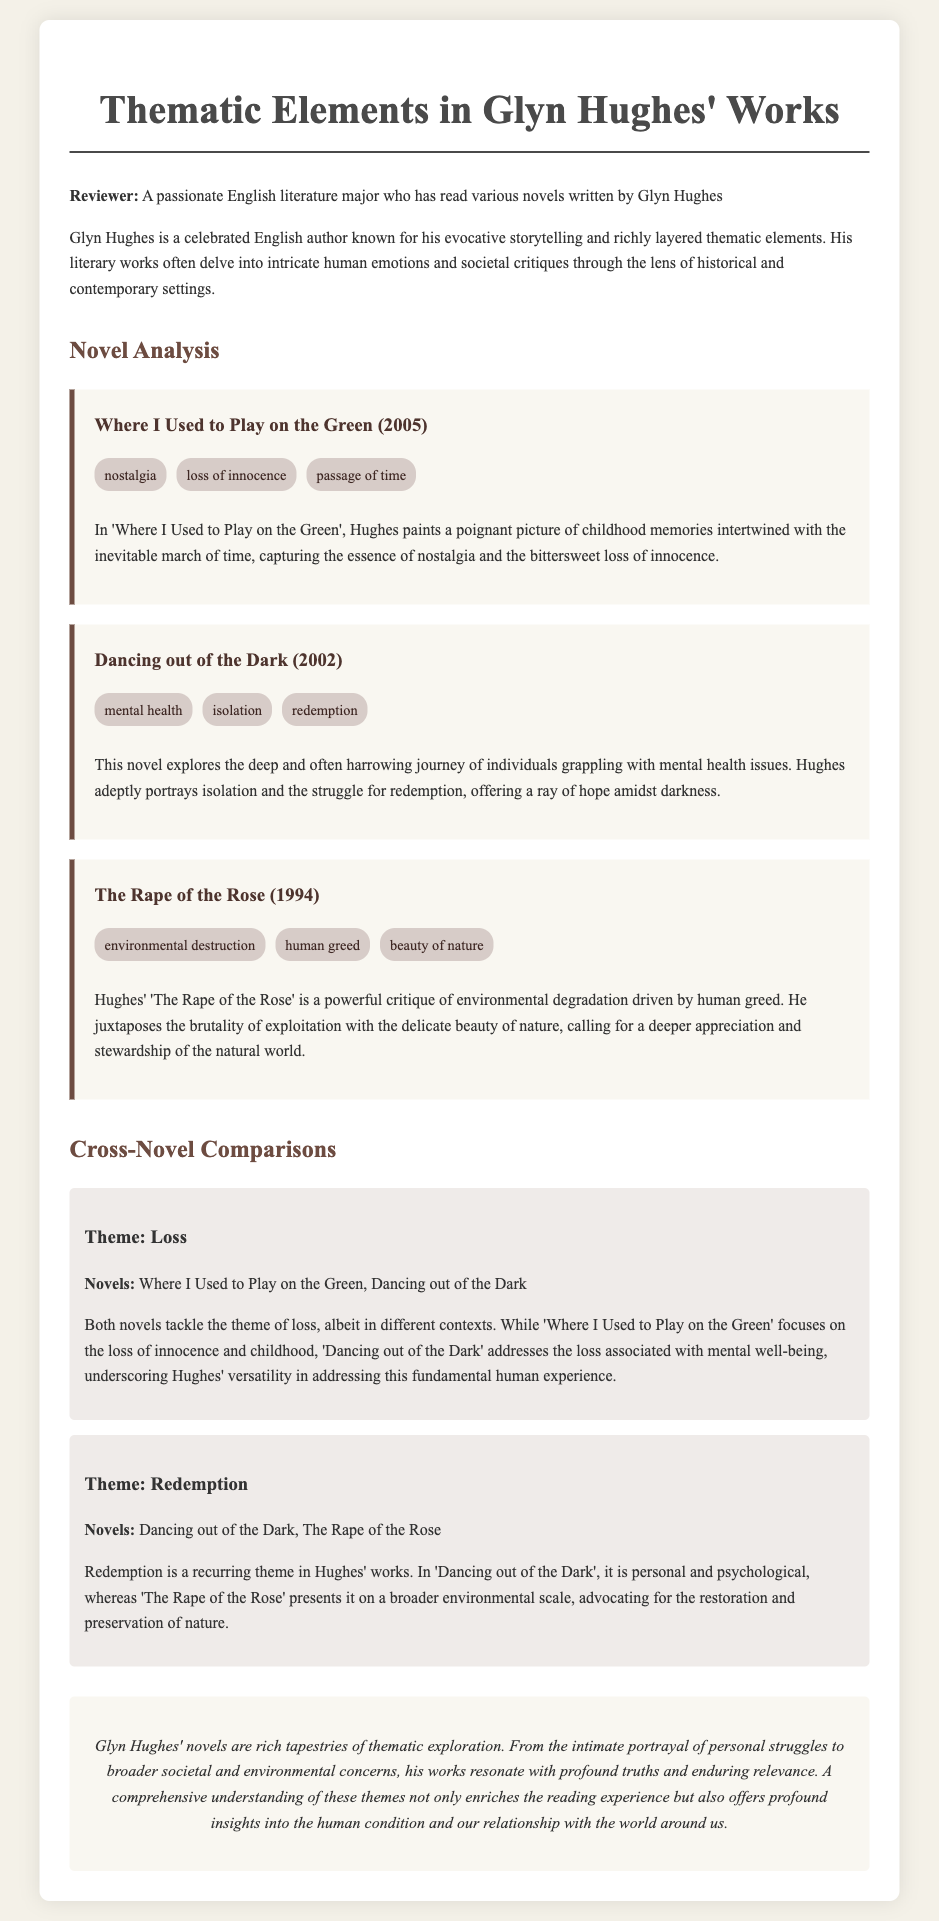What is the title of Glyn Hughes' first novel mentioned? The first novel mentioned in the document is 'The Rape of the Rose'.
Answer: The Rape of the Rose How many themes are highlighted in 'Dancing out of the Dark'? The document lists three themes for 'Dancing out of the Dark'.
Answer: three Which theme is shared between ‘Where I Used to Play on the Green’ and ‘Dancing out of the Dark’? Both novels explore the theme of loss.
Answer: loss What year was 'Where I Used to Play on the Green' published? The publication year for 'Where I Used to Play on the Green' is stated as 2005.
Answer: 2005 Which theme is associated with environmental issues in Glyn Hughes' works? The theme that pertains to environmental issues in the document is environmental destruction.
Answer: environmental destruction What aspect of mental health is explored in 'Dancing out of the Dark'? The novel addresses the theme of isolation related to mental health.
Answer: isolation What is the main critique presented in 'The Rape of the Rose'? The main critique in 'The Rape of the Rose' is against environmental degradation.
Answer: environmental degradation What literary element is Glyn Hughes known for according to the reviewer? The reviewer notes that Hughes is known for evocative storytelling.
Answer: evocative storytelling 